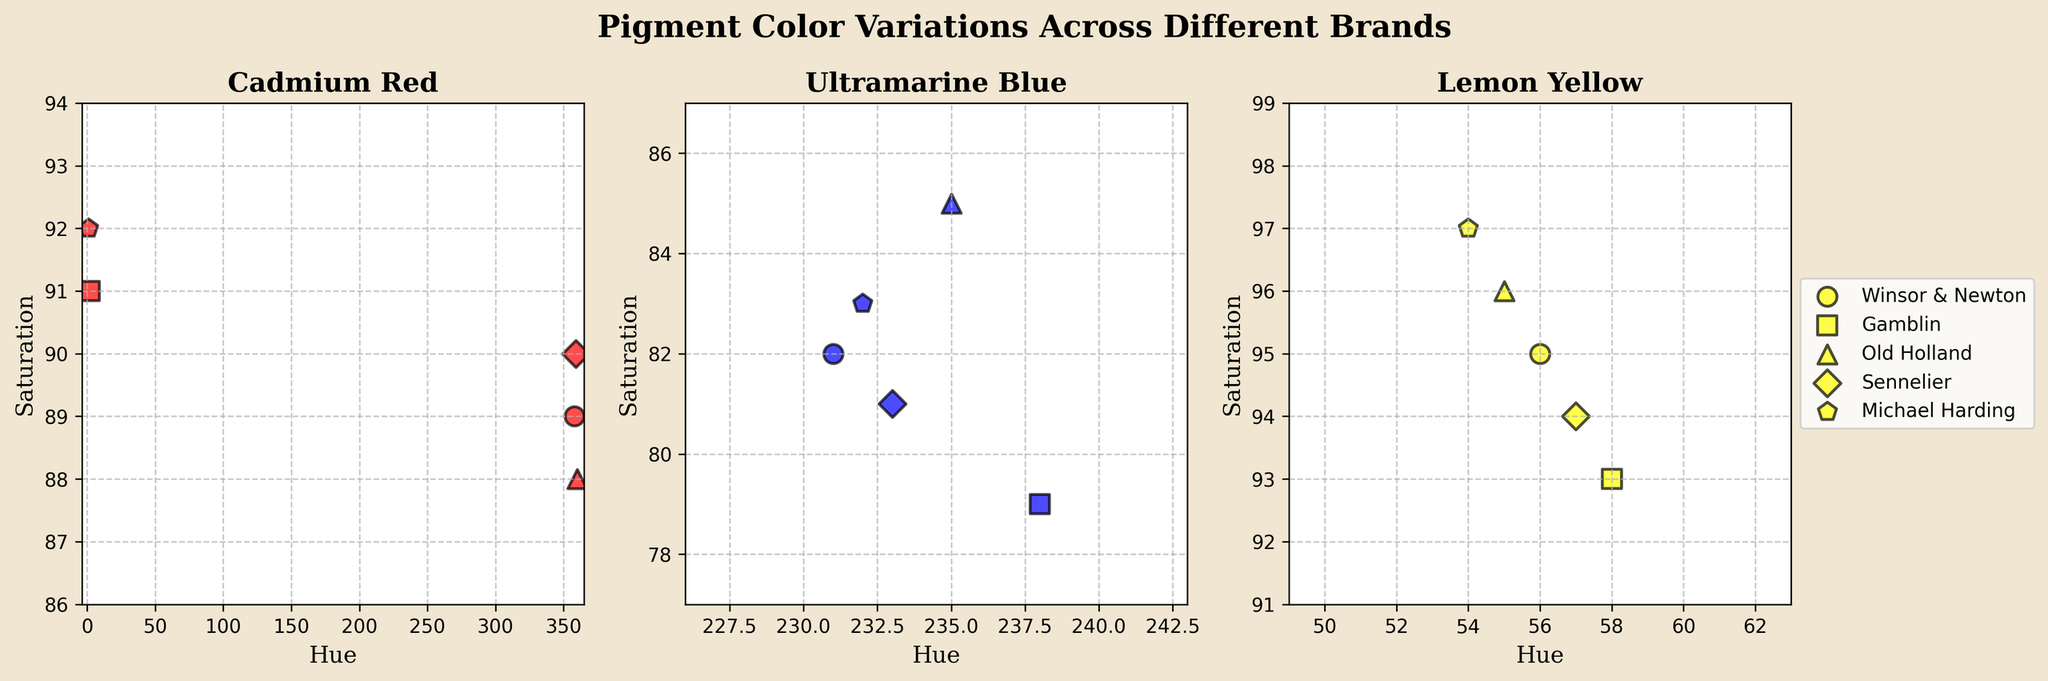How many subplots are in the figure? The figure consists of three scatter plots, each representing different pigment colors (Cadmium Red, Ultramarine Blue, Lemon Yellow) across various brands.
Answer: Three What is the title of the figure? The title is "Pigment Color Variations Across Different Brands".
Answer: Pigment Color Variations Across Different Brands Which brand marker is used for Sennelier paints? By examining the legend in the third subplot, where the legend is located, we see that Sennelier paints are represented by diamond markers.
Answer: Diamond What are the ranges of the hue values for Cadmium Red paints in the subplot? In the Cadmium Red subplot, the hue values range from the minimum value slightly below 0 to a maximum of just above 360 because different brands mark it at slightly different points within this range.
Answer: ~0 to ~360 Which brand's Lemon Yellow has the highest saturation? By looking at the scatter points in the Lemon Yellow subplot, the brand marker located at the highest point on the saturation axis is Michael Harding.
Answer: Michael Harding Which Lemon Yellow paint brand has the lowest hue value? After evaluating the data points in the Lemon Yellow subplot, the point with the lowest hue value corresponds to Michael Harding.
Answer: Michael Harding What is the average saturation value of Ultramarine Blue paints across all brands? Find the saturation values of Ultramarine Blue paints (82, 79, 85, 81, 83). Sum them (82 + 79 + 85 + 81 + 83 = 410) and divide by the number of values (5) to get the average.
Answer: 82 Compare the saturation of Cadmium Red paints between Winsor & Newton and Michael Harding. In the Cadmium Red subplot, Winsor & Newton has a saturation of 89, and Michael Harding has a saturation of 92. Therefore, Michael Harding has a higher saturation than Winsor & Newton.
Answer: Michael Harding Is any brand's Ultramarine Blue paint perfectly aligned in hue and saturation with another brand's Ultramarine Blue paint? Observing the Ulltramarine Blue subplot, no two points overlap exactly in both hue and saturation, indicating no perfect alignment between two brands.
Answer: No Which pigment color has the most saturated paints across brands in general? By comparing the upper bounds of the saturation axes in all three subplots, Lemon Yellow has the highest saturation values, indicating it is the most saturated color among the three.
Answer: Lemon Yellow 